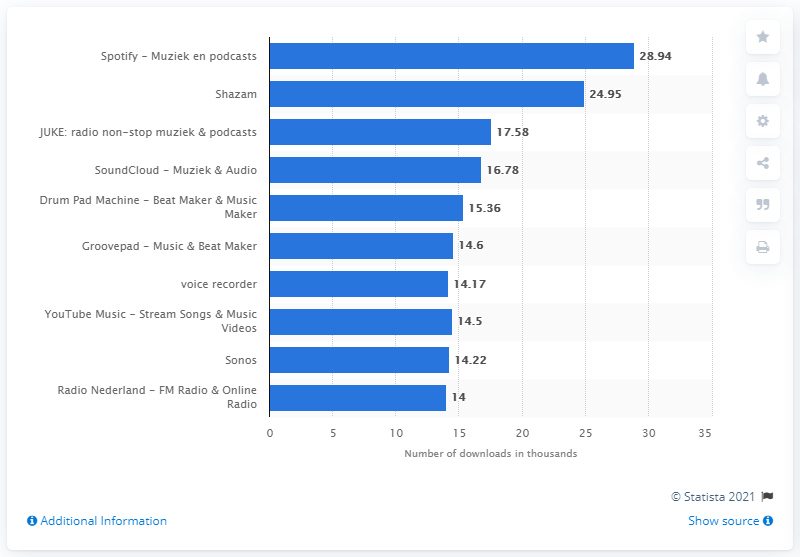Mention a couple of crucial points in this snapshot. There are approximately 8 apps that have fewer than 20,000 downloads. The combined downloads between Sonos and Soundcloud are 31. 